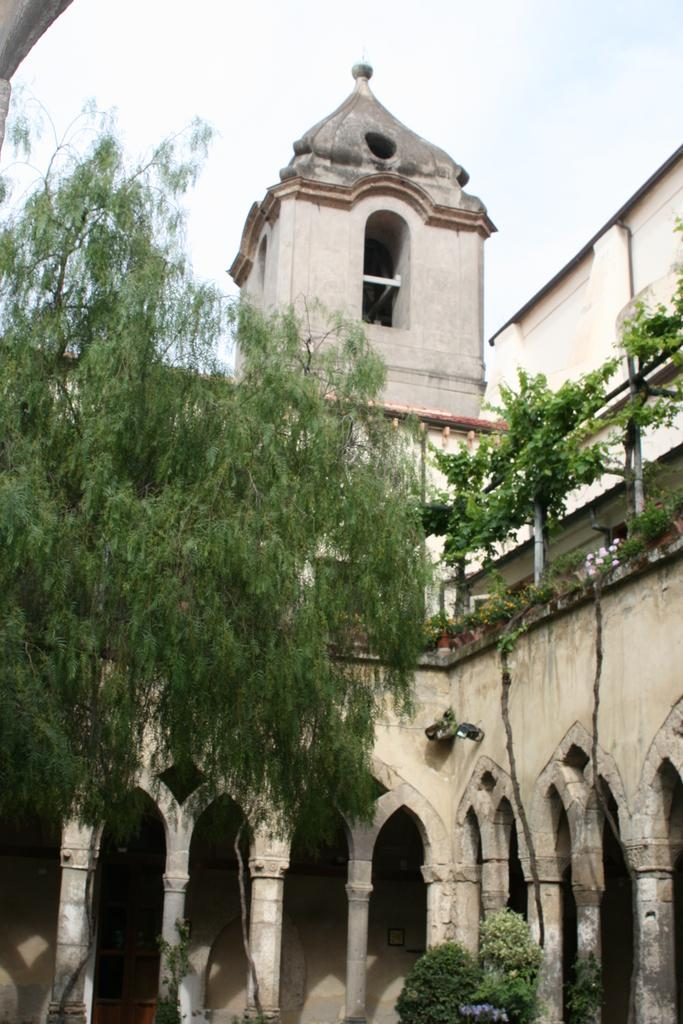What type of structure is visible in the image? There is an old building in the image. What other elements can be seen in the image besides the old building? There are trees in the image. What is the manager doing in the image? There is no manager present in the image. What season is depicted in the image? The provided facts do not mention any season, so it cannot be determined from the image. 